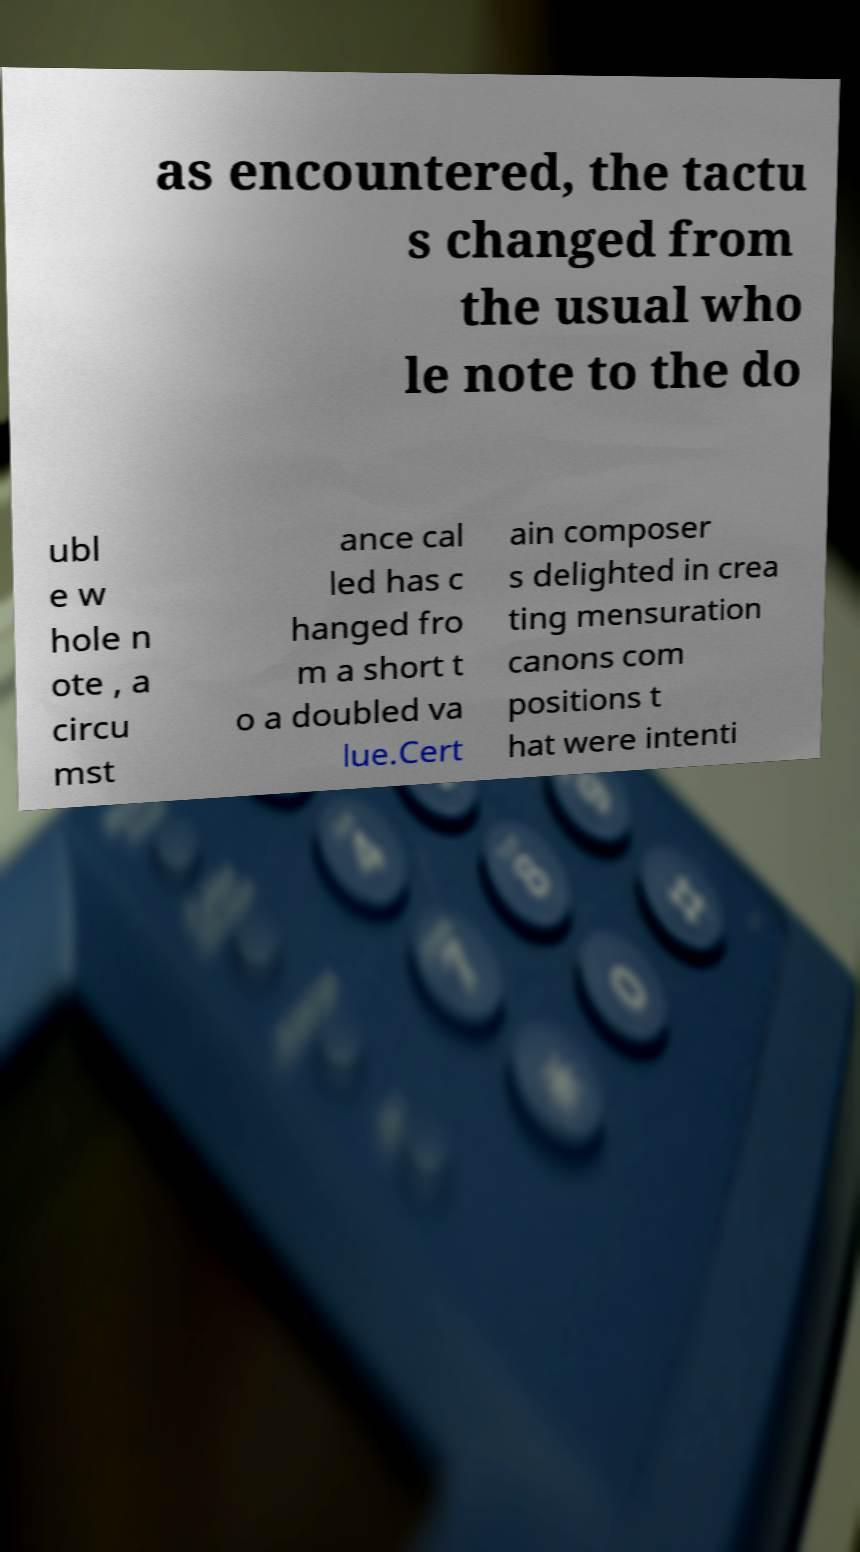Could you extract and type out the text from this image? as encountered, the tactu s changed from the usual who le note to the do ubl e w hole n ote , a circu mst ance cal led has c hanged fro m a short t o a doubled va lue.Cert ain composer s delighted in crea ting mensuration canons com positions t hat were intenti 